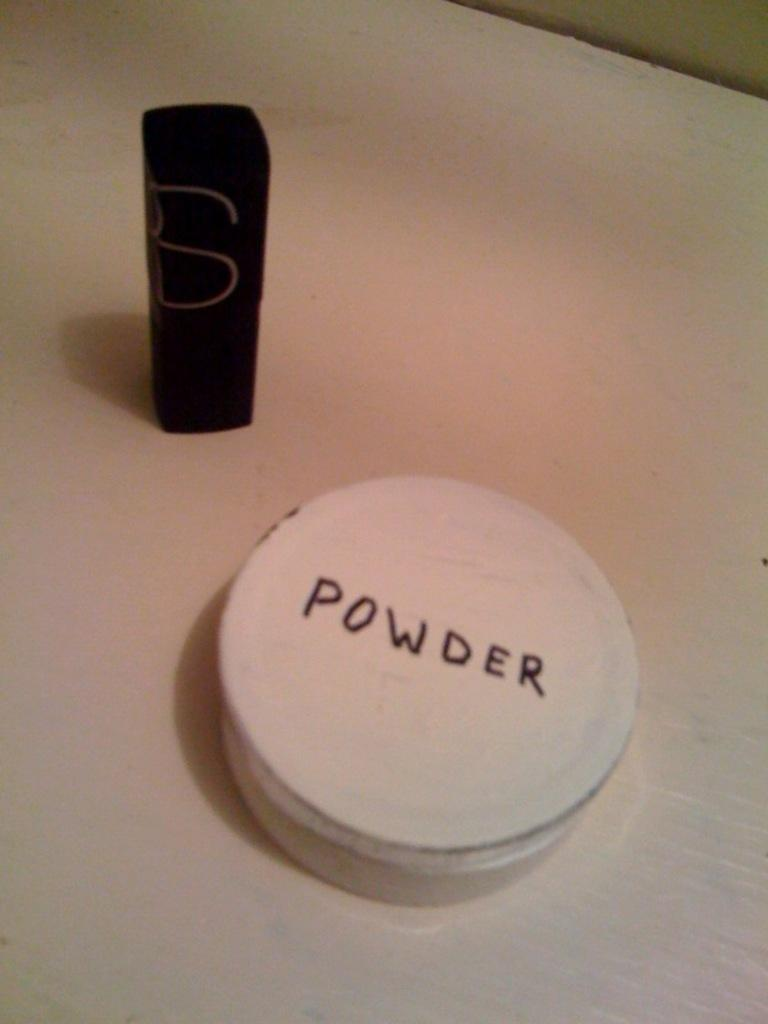<image>
Share a concise interpretation of the image provided. A white container with the word Powder written on the cap 